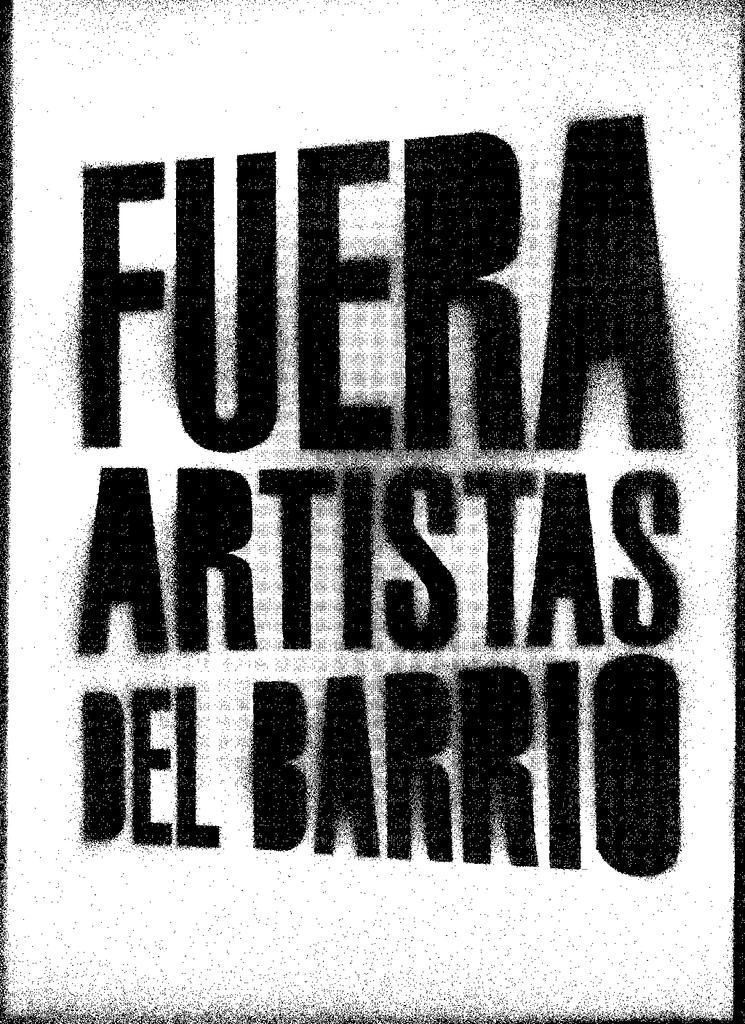<image>
Provide a brief description of the given image. Black and white poster that says "Fuera Artistas Del Barrio". 